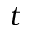<formula> <loc_0><loc_0><loc_500><loc_500>t</formula> 